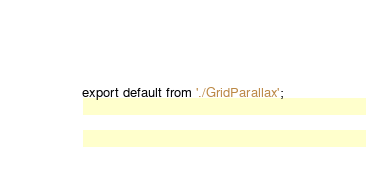Convert code to text. <code><loc_0><loc_0><loc_500><loc_500><_JavaScript_>export default from './GridParallax';
</code> 